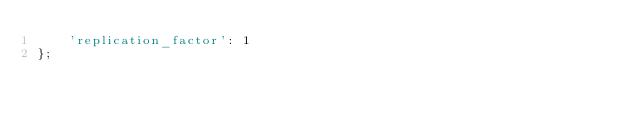Convert code to text. <code><loc_0><loc_0><loc_500><loc_500><_SQL_>    'replication_factor': 1
};
</code> 